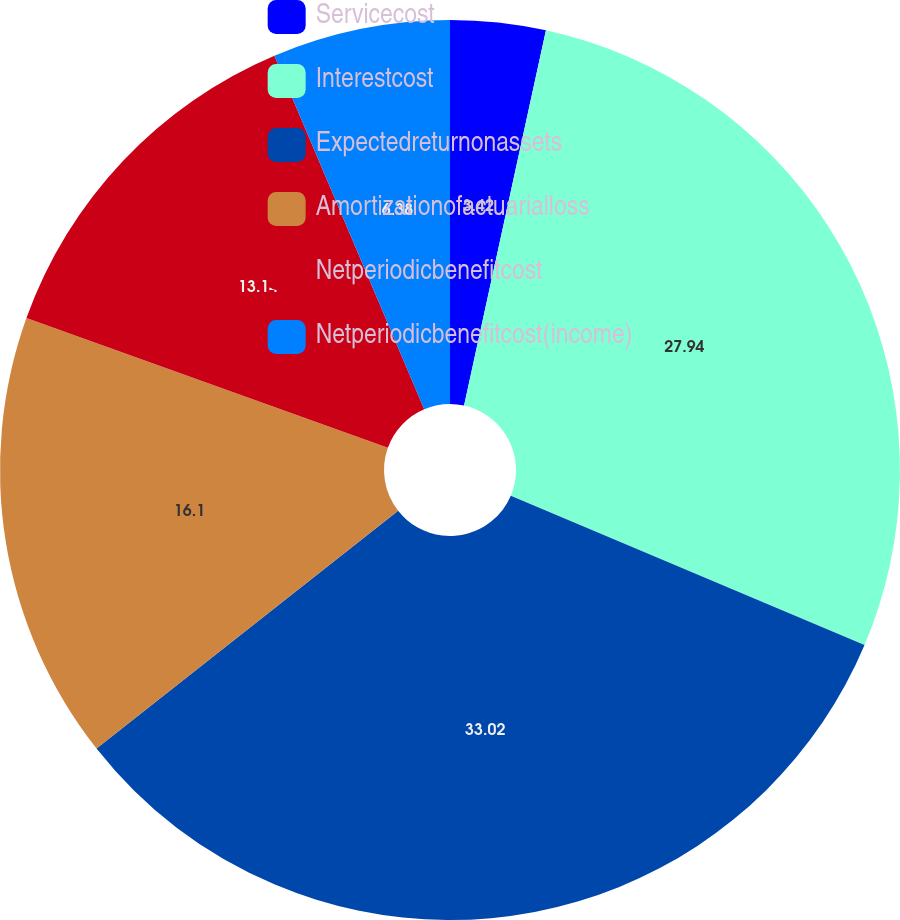<chart> <loc_0><loc_0><loc_500><loc_500><pie_chart><fcel>Servicecost<fcel>Interestcost<fcel>Expectedreturnonassets<fcel>Amortizationofactuarialloss<fcel>Netperiodicbenefitcost<fcel>Netperiodicbenefitcost(income)<nl><fcel>3.42%<fcel>27.94%<fcel>33.02%<fcel>16.1%<fcel>13.14%<fcel>6.38%<nl></chart> 